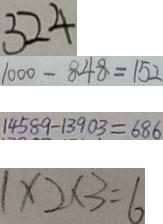Convert formula to latex. <formula><loc_0><loc_0><loc_500><loc_500>3 2 4 
 1 0 0 0 - 8 4 8 = 1 5 2 
 1 4 5 8 9 - 1 3 9 0 3 = 6 8 6 
 1 \times 2 \times 3 = 6</formula> 